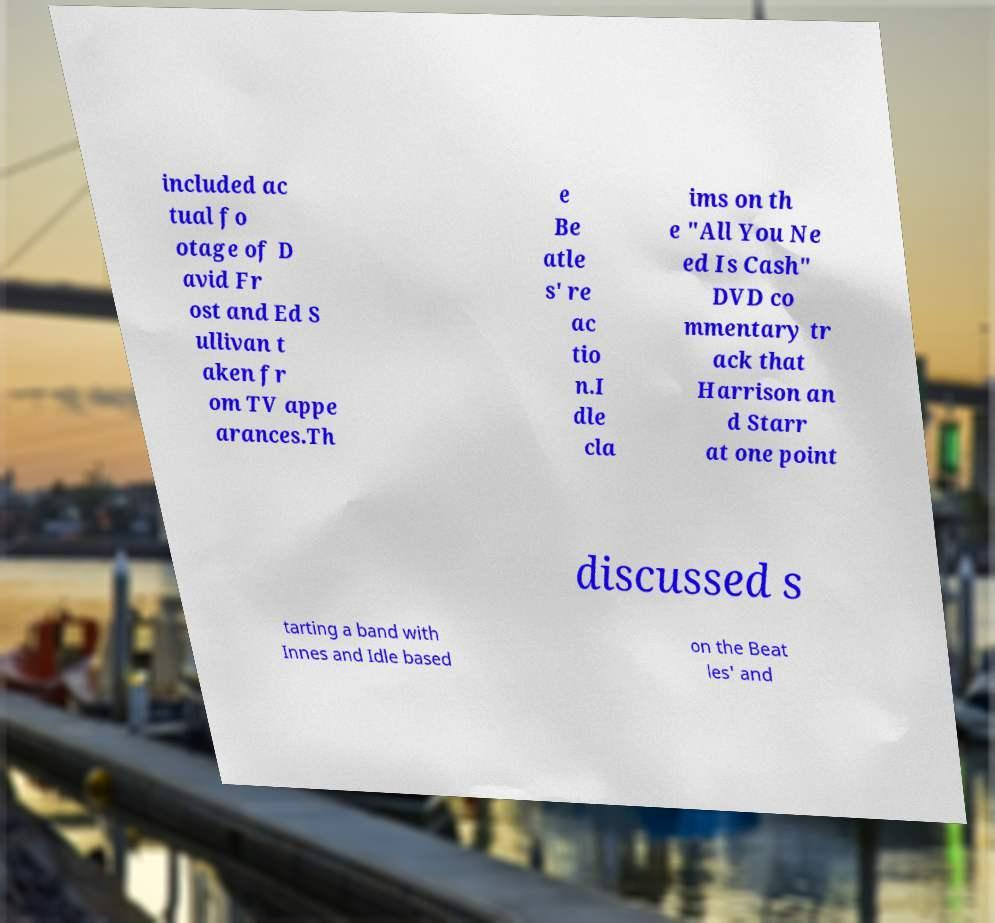I need the written content from this picture converted into text. Can you do that? included ac tual fo otage of D avid Fr ost and Ed S ullivan t aken fr om TV appe arances.Th e Be atle s' re ac tio n.I dle cla ims on th e "All You Ne ed Is Cash" DVD co mmentary tr ack that Harrison an d Starr at one point discussed s tarting a band with Innes and Idle based on the Beat les' and 